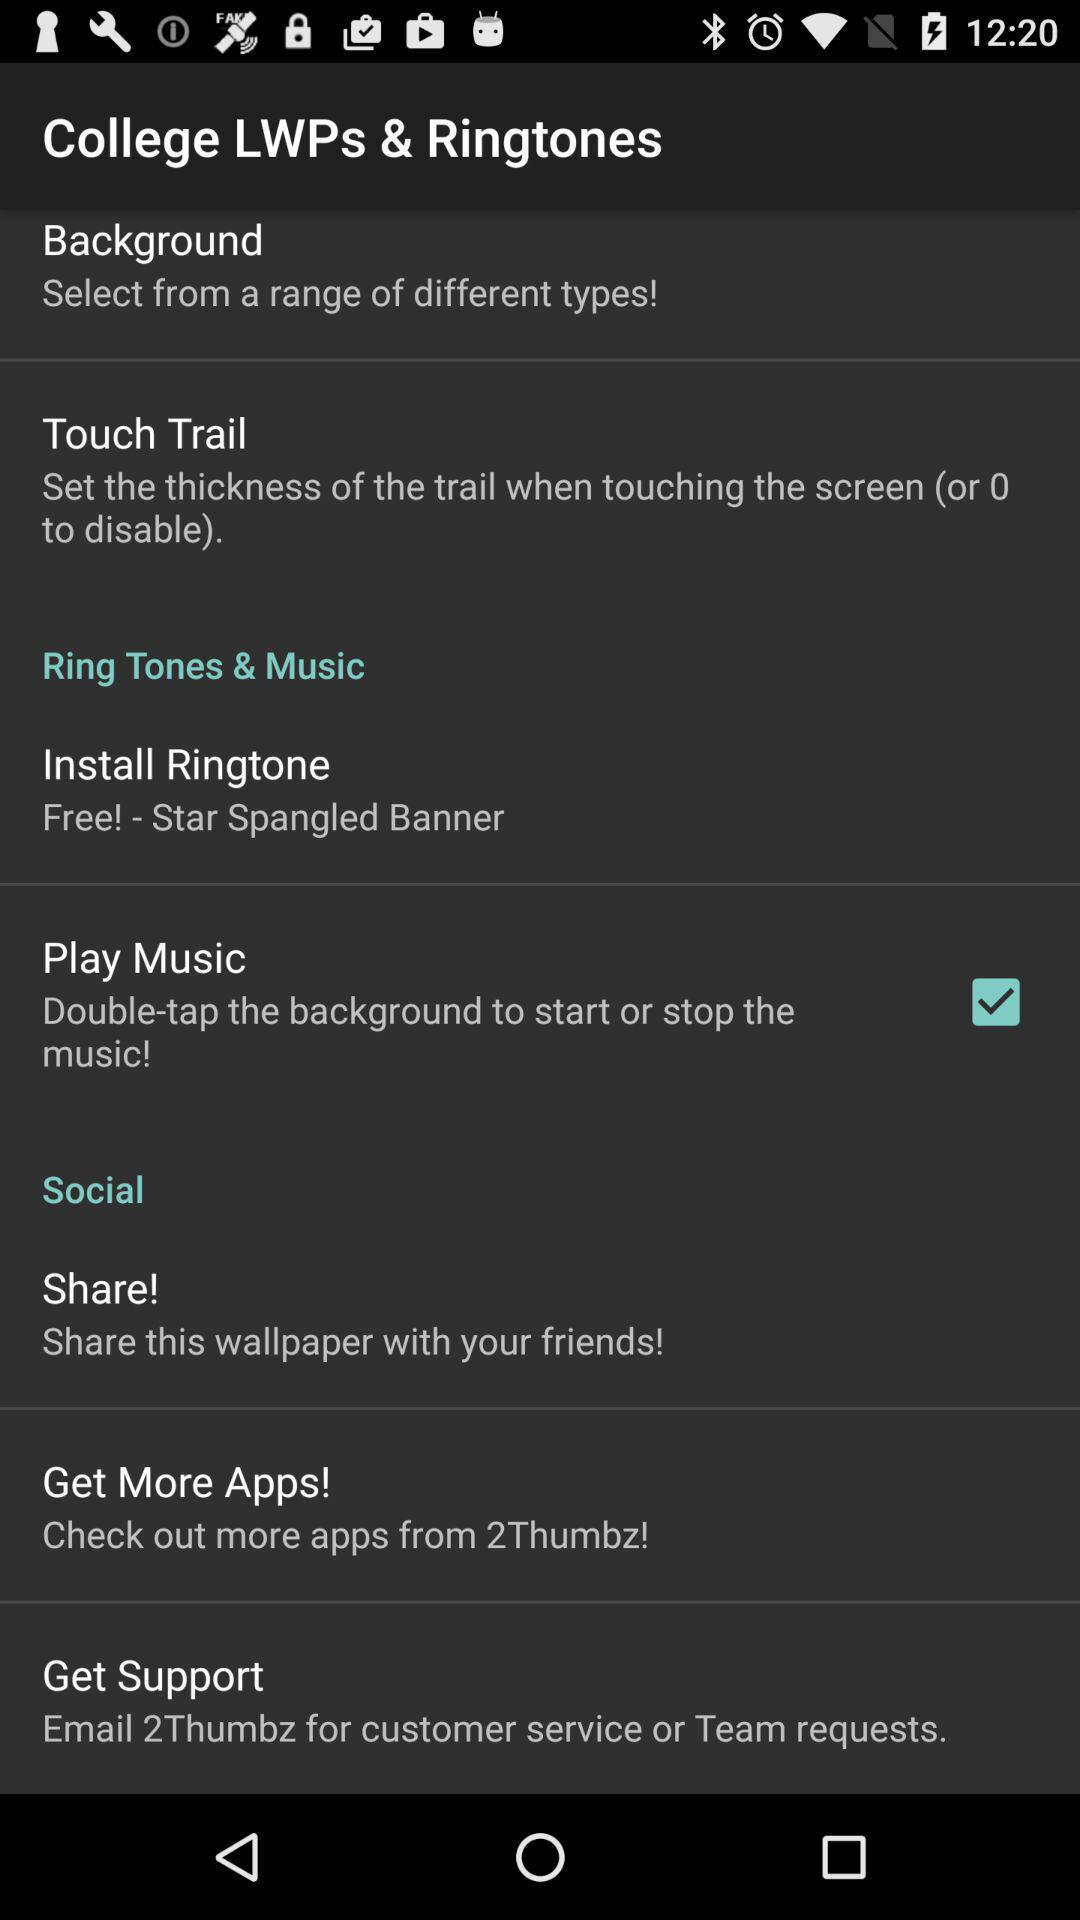From where can more apps be checked? More apps can be checked from "2Thumbz". 